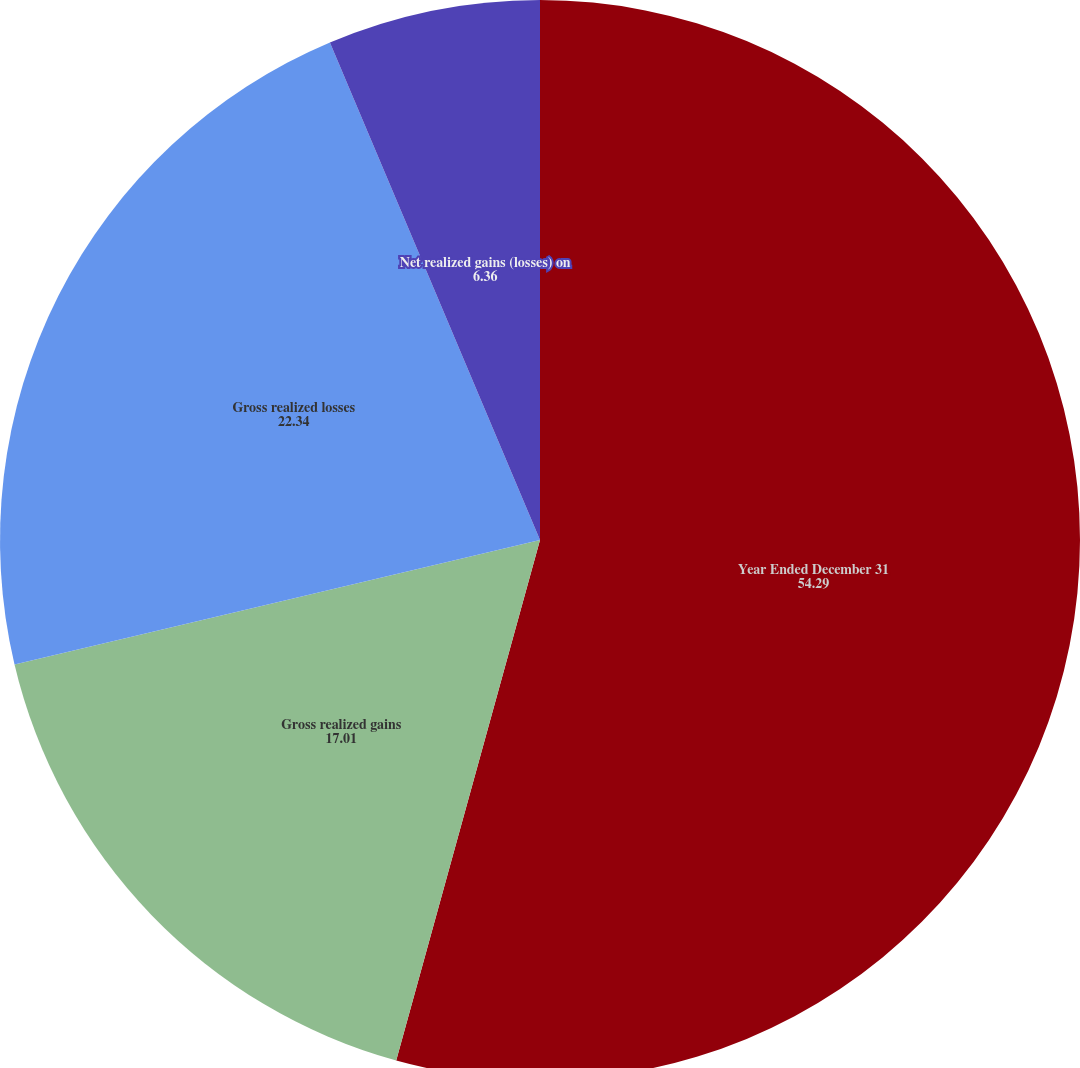Convert chart to OTSL. <chart><loc_0><loc_0><loc_500><loc_500><pie_chart><fcel>Year Ended December 31<fcel>Gross realized gains<fcel>Gross realized losses<fcel>Net realized gains (losses) on<nl><fcel>54.29%<fcel>17.01%<fcel>22.34%<fcel>6.36%<nl></chart> 